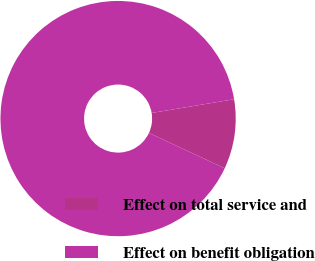Convert chart. <chart><loc_0><loc_0><loc_500><loc_500><pie_chart><fcel>Effect on total service and<fcel>Effect on benefit obligation<nl><fcel>9.57%<fcel>90.43%<nl></chart> 